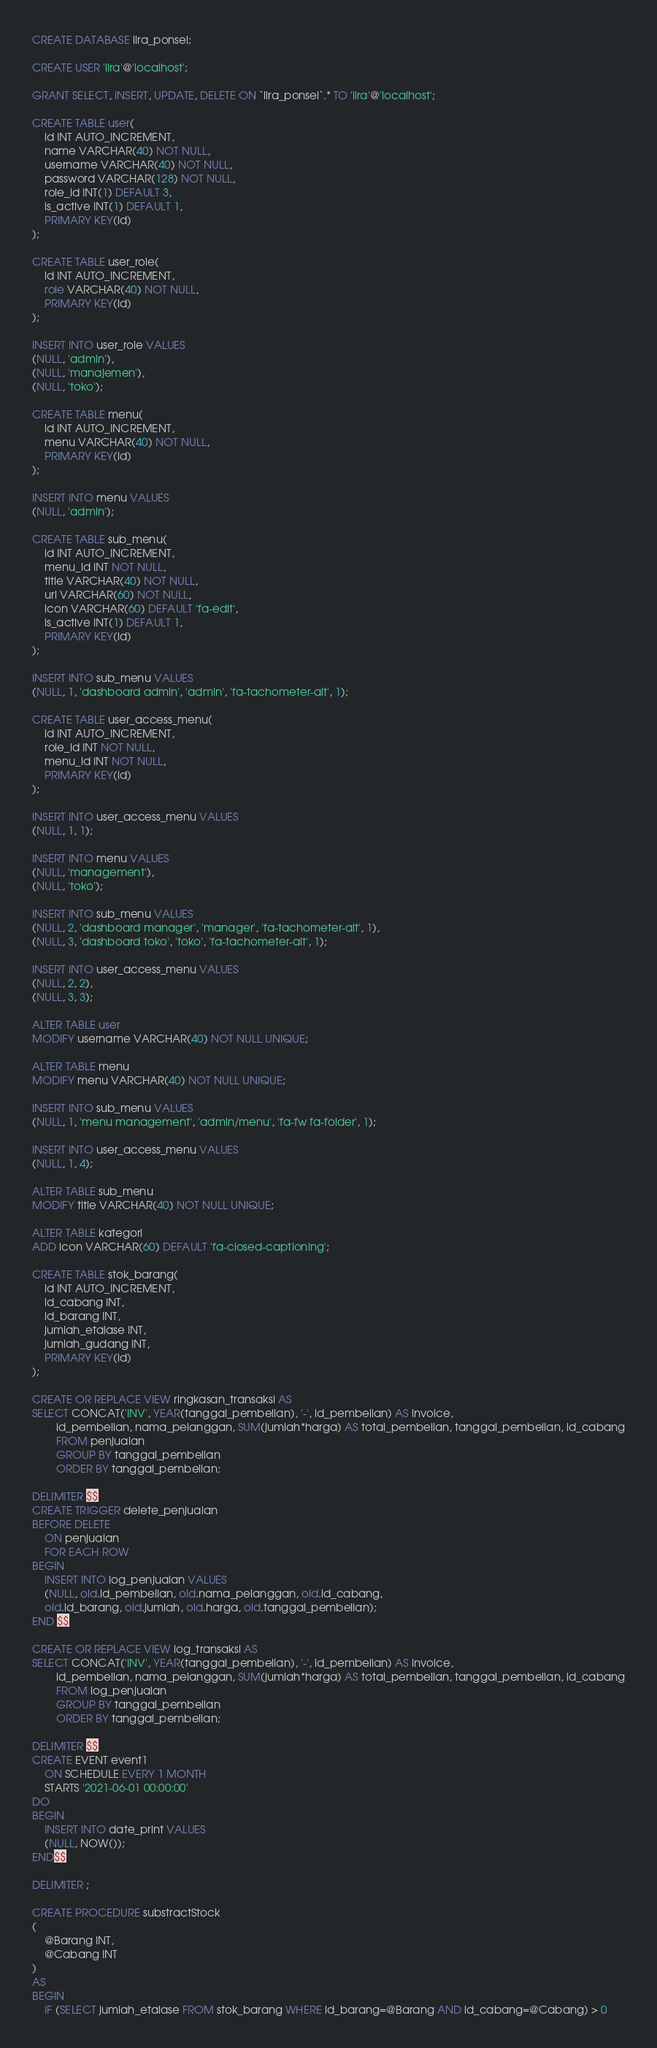<code> <loc_0><loc_0><loc_500><loc_500><_SQL_>CREATE DATABASE lira_ponsel;

CREATE USER 'lira'@'localhost';

GRANT SELECT, INSERT, UPDATE, DELETE ON `lira_ponsel`.* TO 'lira'@'localhost';

CREATE TABLE user(
	id INT AUTO_INCREMENT,
	name VARCHAR(40) NOT NULL,
	username VARCHAR(40) NOT NULL,
	password VARCHAR(128) NOT NULL,
	role_id INT(1) DEFAULT 3,
	is_active INT(1) DEFAULT 1,
	PRIMARY KEY(id)
);

CREATE TABLE user_role(
	id INT AUTO_INCREMENT,
	role VARCHAR(40) NOT NULL,
	PRIMARY KEY(id)
);

INSERT INTO user_role VALUES
(NULL, 'admin'),
(NULL, 'manajemen'),
(NULL, 'toko');

CREATE TABLE menu(
	id INT AUTO_INCREMENT,
	menu VARCHAR(40) NOT NULL,
	PRIMARY KEY(id)
);

INSERT INTO menu VALUES
(NULL, 'admin');

CREATE TABLE sub_menu(
	id INT AUTO_INCREMENT,
	menu_id INT NOT NULL,
	title VARCHAR(40) NOT NULL,
	url VARCHAR(60) NOT NULL,
	icon VARCHAR(60) DEFAULT 'fa-edit',
	is_active INT(1) DEFAULT 1,
	PRIMARY KEY(id)
);

INSERT INTO sub_menu VALUES
(NULL, 1, 'dashboard admin', 'admin', 'fa-tachometer-alt', 1);

CREATE TABLE user_access_menu(
	id INT AUTO_INCREMENT,
	role_id INT NOT NULL,
	menu_id INT NOT NULL,
	PRIMARY KEY(id)
);

INSERT INTO user_access_menu VALUES
(NULL, 1, 1);

INSERT INTO menu VALUES
(NULL, 'management'),
(NULL, 'toko');

INSERT INTO sub_menu VALUES
(NULL, 2, 'dashboard manager', 'manager', 'fa-tachometer-alt', 1),
(NULL, 3, 'dashboard toko', 'toko', 'fa-tachometer-alt', 1);

INSERT INTO user_access_menu VALUES
(NULL, 2, 2),
(NULL, 3, 3);

ALTER TABLE user
MODIFY username VARCHAR(40) NOT NULL UNIQUE;

ALTER TABLE menu
MODIFY menu VARCHAR(40) NOT NULL UNIQUE;

INSERT INTO sub_menu VALUES
(NULL, 1, 'menu management', 'admin/menu', 'fa-fw fa-folder', 1);

INSERT INTO user_access_menu VALUES
(NULL, 1, 4);

ALTER TABLE sub_menu
MODIFY title VARCHAR(40) NOT NULL UNIQUE;

ALTER TABLE kategori
ADD icon VARCHAR(60) DEFAULT 'fa-closed-captioning';

CREATE TABLE stok_barang(
	id INT AUTO_INCREMENT,
	id_cabang INT,
	id_barang INT,
	jumlah_etalase INT,
	jumlah_gudang INT,
	PRIMARY KEY(id)
);

CREATE OR REPLACE VIEW ringkasan_transaksi AS
SELECT CONCAT('INV', YEAR(tanggal_pembelian), '-', id_pembelian) AS invoice,
		id_pembelian, nama_pelanggan, SUM(jumlah*harga) AS total_pembelian, tanggal_pembelian, id_cabang
		FROM penjualan 
		GROUP BY tanggal_pembelian
		ORDER BY tanggal_pembelian;

DELIMITER $$
CREATE TRIGGER delete_penjualan
BEFORE DELETE
	ON penjualan
	FOR EACH ROW
BEGIN
	INSERT INTO log_penjualan VALUES
	(NULL, old.id_pembelian, old.nama_pelanggan, old.id_cabang,
	old.id_barang, old.jumlah, old.harga, old.tanggal_pembelian);
END $$
		
CREATE OR REPLACE VIEW log_transaksi AS
SELECT CONCAT('INV', YEAR(tanggal_pembelian), '-', id_pembelian) AS invoice,
		id_pembelian, nama_pelanggan, SUM(jumlah*harga) AS total_pembelian, tanggal_pembelian, id_cabang
		FROM log_penjualan 
		GROUP BY tanggal_pembelian
		ORDER BY tanggal_pembelian;

DELIMITER $$
CREATE EVENT event1
	ON SCHEDULE EVERY 1 MONTH
	STARTS '2021-06-01 00:00:00'
DO 
BEGIN
	INSERT INTO date_print VALUES
	(NULL, NOW());
END$$

DELIMITER ;

CREATE PROCEDURE substractStock
(
	@Barang INT,
	@Cabang INT
)
AS
BEGIN
	IF (SELECT jumlah_etalase FROM stok_barang WHERE id_barang=@Barang AND id_cabang=@Cabang) > 0
</code> 